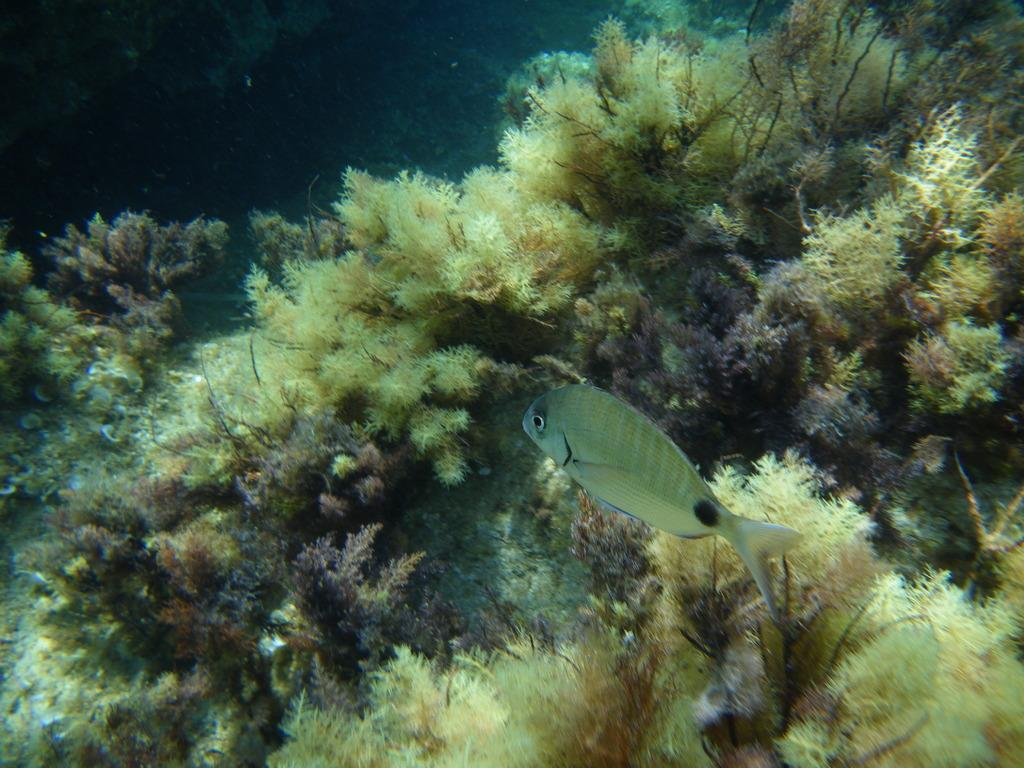What type of animals can be seen in the image? There are fish in the image. What other marine life can be observed in the image? The image features marine life, but no specific details are provided. What type of swing can be seen in the image? There is no swing present in the image; it features fish and marine life. What color is the coat worn by the fish in the image? There is no coat present in the image, as fish do not wear clothing. 